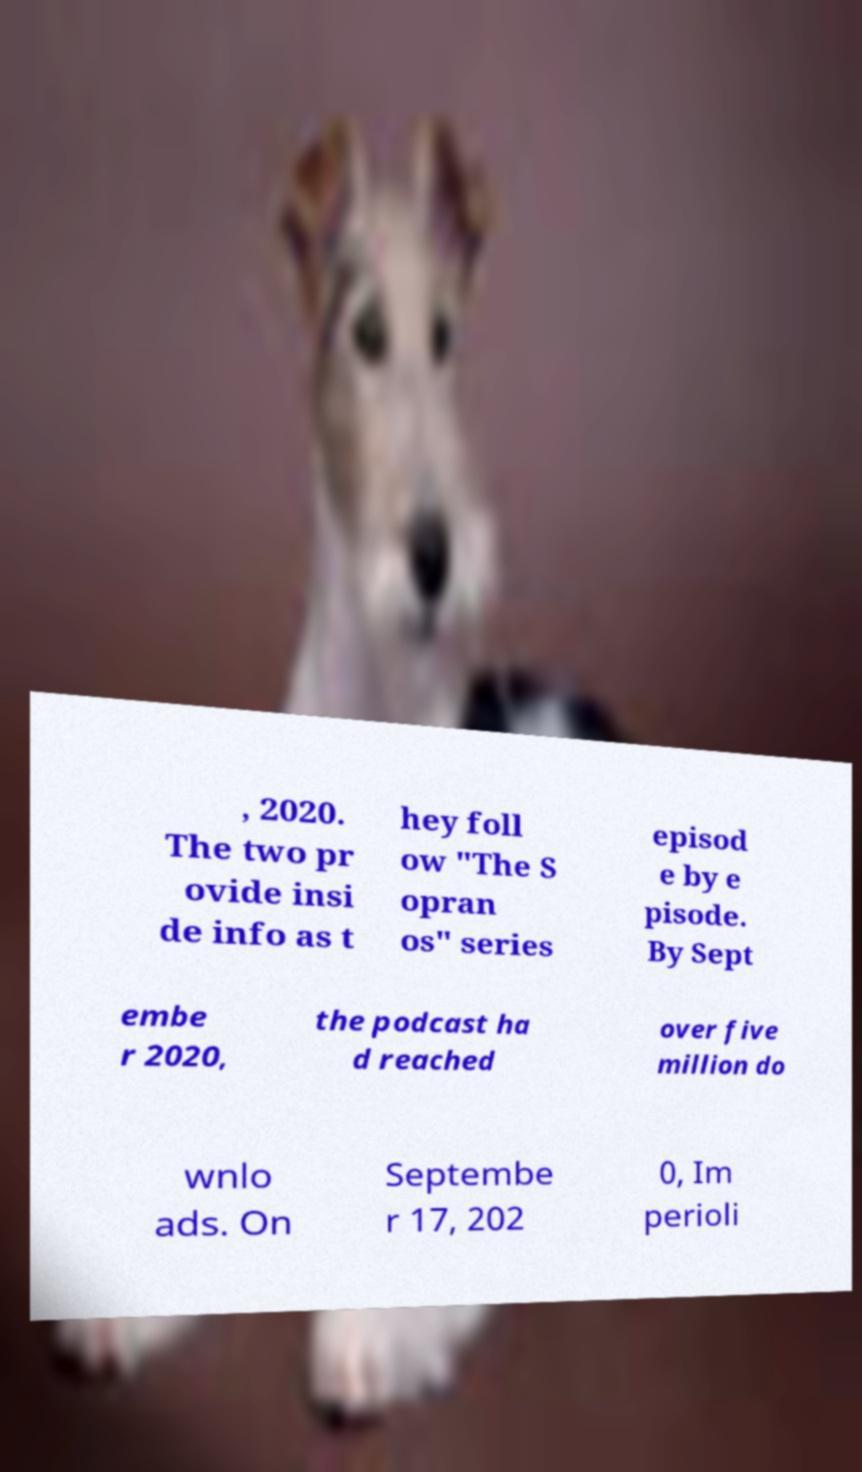Could you assist in decoding the text presented in this image and type it out clearly? , 2020. The two pr ovide insi de info as t hey foll ow "The S opran os" series episod e by e pisode. By Sept embe r 2020, the podcast ha d reached over five million do wnlo ads. On Septembe r 17, 202 0, Im perioli 